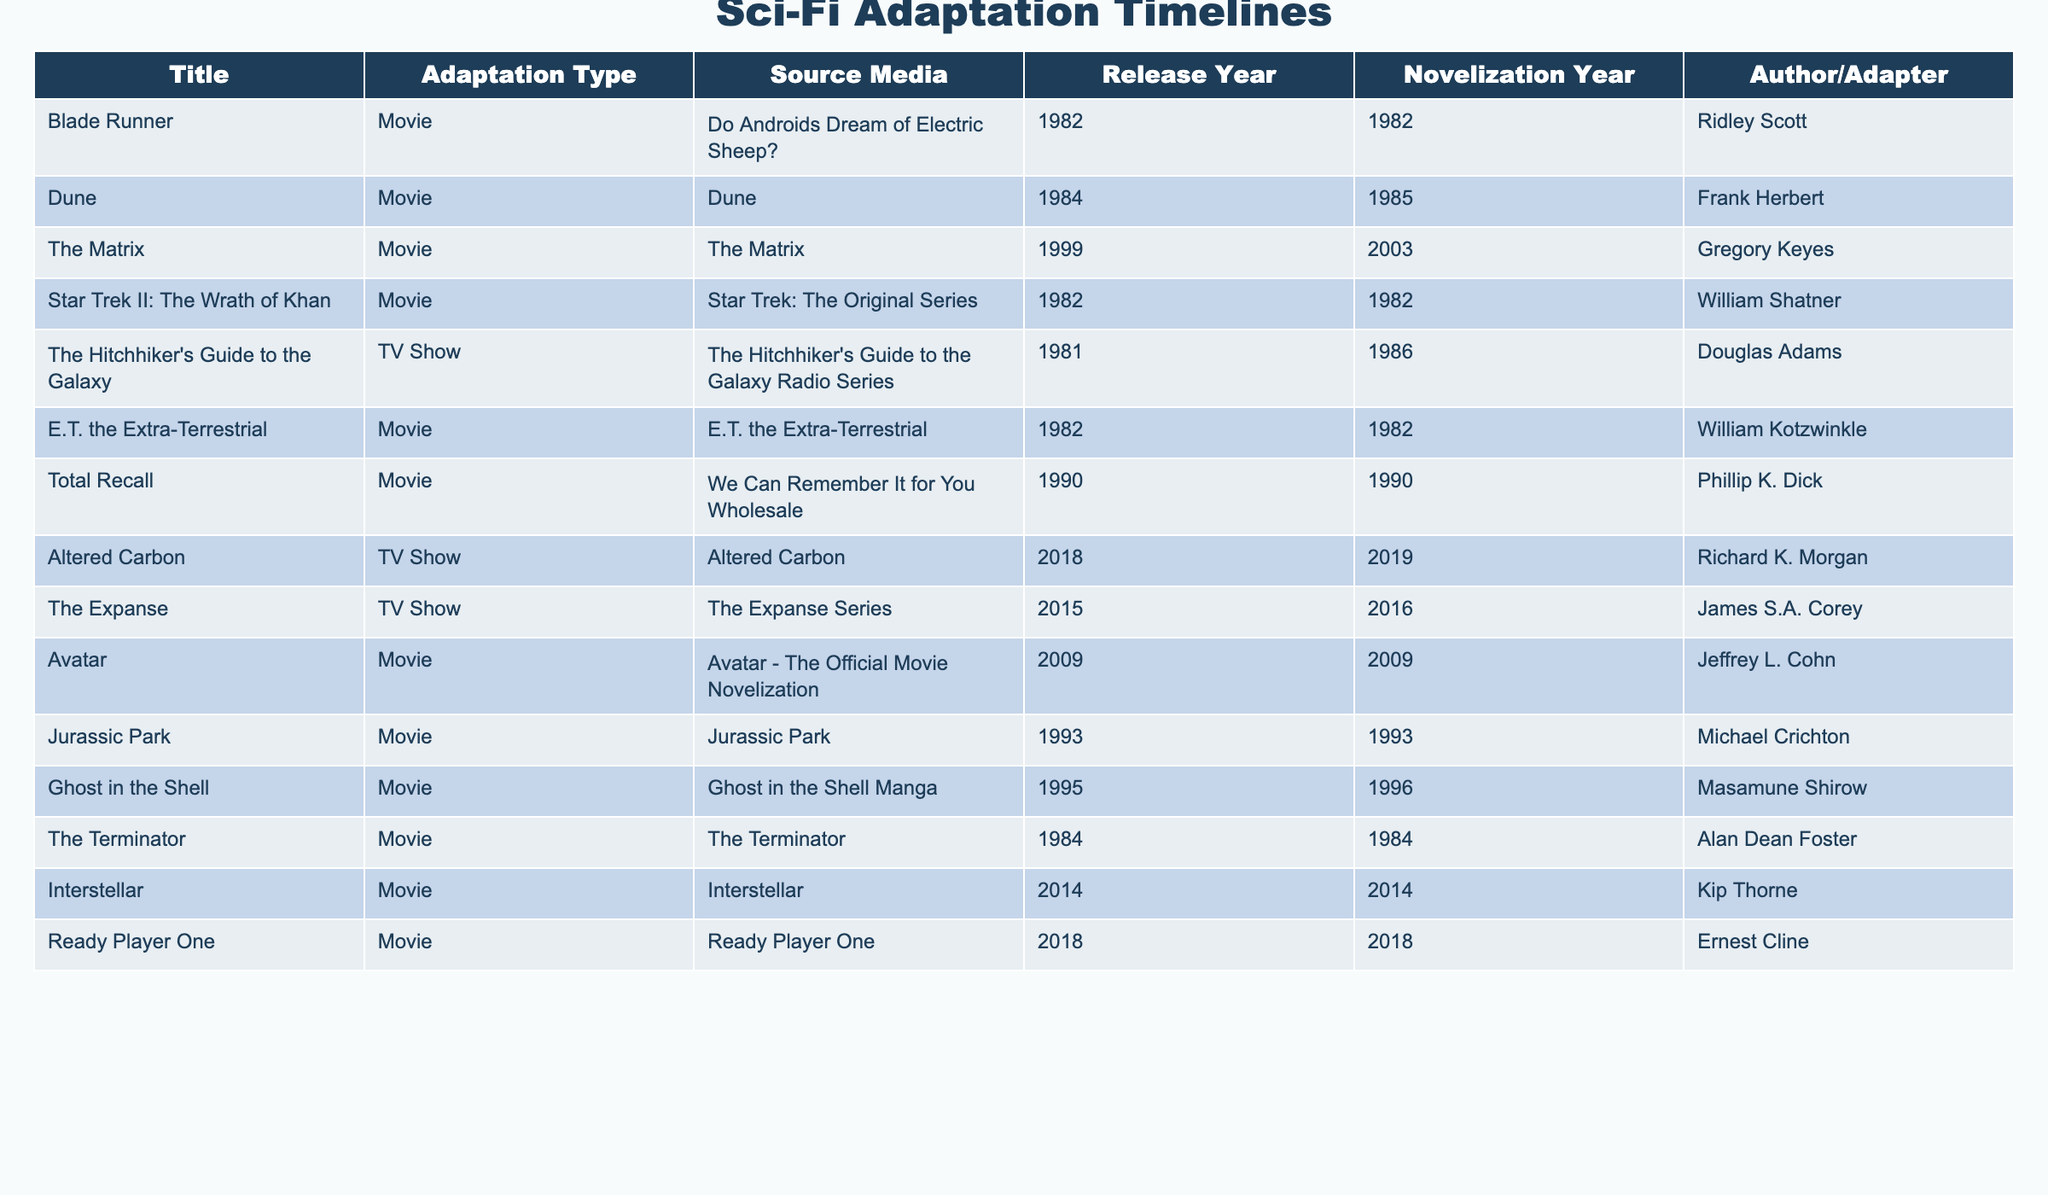What is the release year of "Blade Runner"? The table lists "Blade Runner" under the Title column, and the corresponding Release Year is in the same row, which is 1982.
Answer: 1982 Who wrote the novelization for "Jurassic Park"? The table shows "Jurassic Park" in the Title column, and looking across that row, the Author/Adapter listed is Michael Crichton.
Answer: Michael Crichton Was there a novelization for "The Matrix"? The table indicates that "The Matrix" does have a novelization, which was released in 2003, hence the answer is yes.
Answer: Yes Which adaptation type has more entries: Movie or TV Show? There are 11 entries for Movie and 3 entries for TV Show in the Adaptation Type column. Thus, Movies have more entries than TV Shows.
Answer: Movies How many years after the movie release was the novelization for "Dune" published? The novelization for "Dune" was published in 1985, which is one year after its movie release in 1984 (1985 - 1984 = 1).
Answer: 1 What is the difference in years between the release of "Interstellar" and its novelization? Both the Release Year and the Novelization Year for "Interstellar" are 2014, making the difference 2014 - 2014 = 0.
Answer: 0 Name the author who adapted "Altered Carbon". Looking at the title "Altered Carbon" in the table, the Author/Adapter listed in the corresponding row is Richard K. Morgan.
Answer: Richard K. Morgan Which movie has the latest release year, and what is that year? By checking the Release Year, "Ready Player One" has the latest entry at 2018.
Answer: 2018 Which movie's novelization was published the same year as its release? The entries for "Blade Runner," "E.T. the Extra-Terrestrial," "Total Recall," "The Terminator," "Interstellar," and "Ready Player One" all have their novelization years matching their release years, indicating they were published the same year.
Answer: Multiple entries How many adaptations were published in the 1980s? By reviewing the years in the table, there are 6 adaptations from the 1980s: "Blade Runner," "Dune," "Star Trek II: The Wrath of Khan," "The Hitchhiker's Guide to the Galaxy," "The Terminator," and "Ghost in the Shell." (1982, 1984, 1982, 1981, 1984, 1995)
Answer: 6 